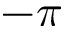Convert formula to latex. <formula><loc_0><loc_0><loc_500><loc_500>- \pi</formula> 